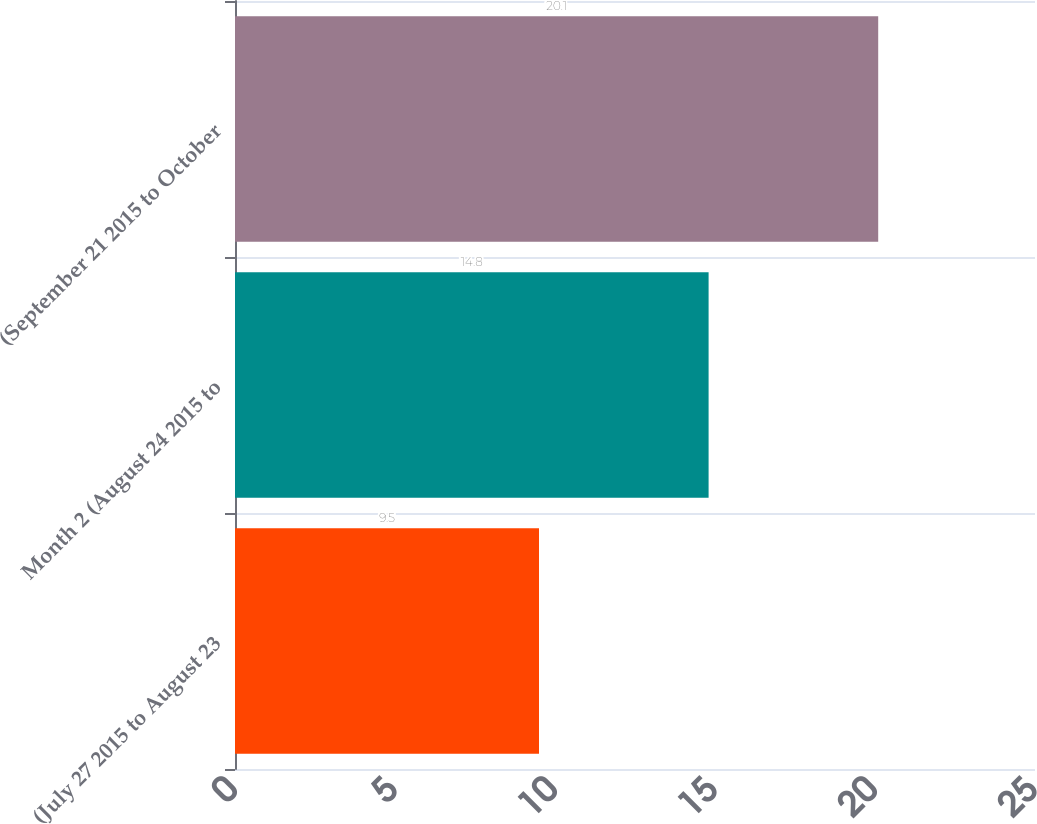Convert chart to OTSL. <chart><loc_0><loc_0><loc_500><loc_500><bar_chart><fcel>(July 27 2015 to August 23<fcel>Month 2 (August 24 2015 to<fcel>(September 21 2015 to October<nl><fcel>9.5<fcel>14.8<fcel>20.1<nl></chart> 